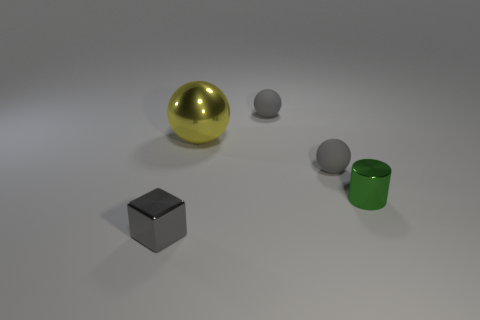Are there more big yellow metallic balls than metal objects?
Keep it short and to the point. No. There is a tiny matte ball in front of the large metal sphere; is it the same color as the small block?
Provide a short and direct response. Yes. What number of things are small shiny things that are behind the tiny cube or gray balls behind the green metal thing?
Offer a very short reply. 3. What number of objects are in front of the big yellow ball and to the left of the green thing?
Offer a very short reply. 2. What is the shape of the small metallic object that is behind the small gray block left of the small gray rubber ball behind the yellow metallic thing?
Offer a very short reply. Cylinder. What is the small gray object that is both right of the gray metal object and in front of the big yellow shiny thing made of?
Provide a short and direct response. Rubber. What color is the small metal thing that is to the left of the small shiny object right of the small metal thing on the left side of the yellow thing?
Give a very brief answer. Gray. How many gray things are rubber things or metal things?
Provide a short and direct response. 3. How many other things are there of the same size as the metallic cylinder?
Your answer should be very brief. 3. How many small metal spheres are there?
Your answer should be compact. 0. 